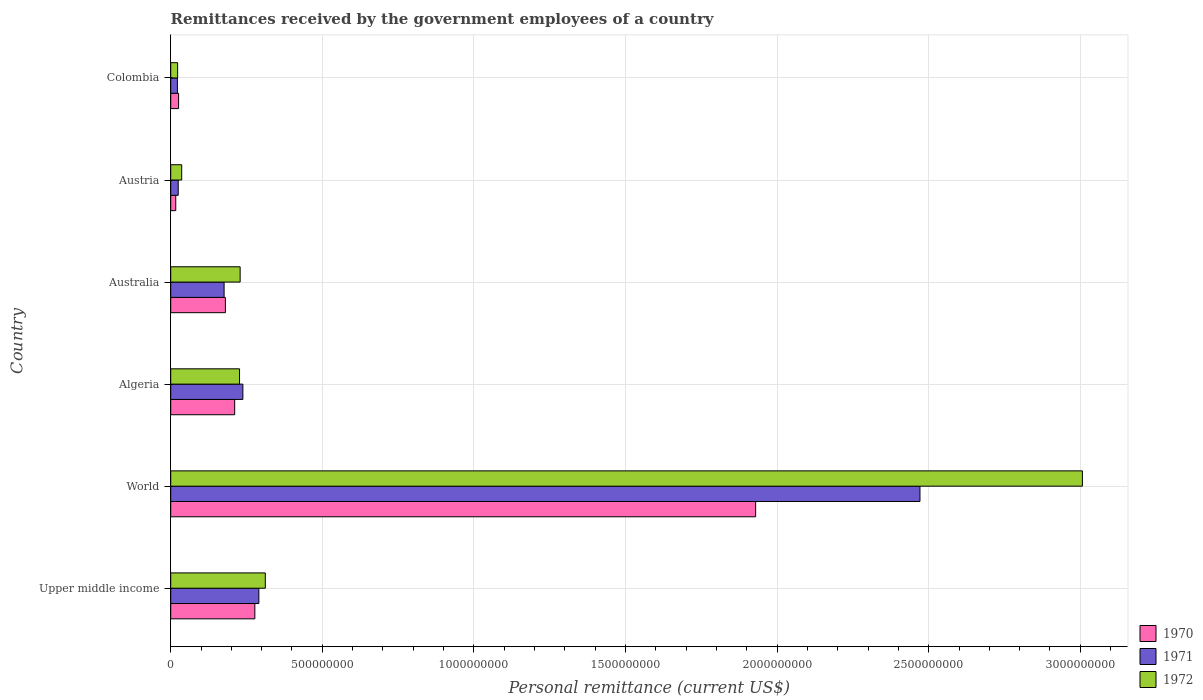Are the number of bars on each tick of the Y-axis equal?
Offer a terse response. Yes. How many bars are there on the 6th tick from the bottom?
Offer a terse response. 3. What is the label of the 6th group of bars from the top?
Offer a very short reply. Upper middle income. What is the remittances received by the government employees in 1970 in Austria?
Give a very brief answer. 1.66e+07. Across all countries, what is the maximum remittances received by the government employees in 1970?
Provide a succinct answer. 1.93e+09. Across all countries, what is the minimum remittances received by the government employees in 1970?
Keep it short and to the point. 1.66e+07. In which country was the remittances received by the government employees in 1972 maximum?
Give a very brief answer. World. In which country was the remittances received by the government employees in 1970 minimum?
Offer a very short reply. Austria. What is the total remittances received by the government employees in 1972 in the graph?
Offer a very short reply. 3.83e+09. What is the difference between the remittances received by the government employees in 1972 in Austria and that in Colombia?
Keep it short and to the point. 1.34e+07. What is the difference between the remittances received by the government employees in 1972 in Algeria and the remittances received by the government employees in 1970 in Austria?
Your answer should be compact. 2.10e+08. What is the average remittances received by the government employees in 1971 per country?
Provide a succinct answer. 5.37e+08. What is the difference between the remittances received by the government employees in 1971 and remittances received by the government employees in 1972 in Austria?
Your response must be concise. -1.15e+07. What is the ratio of the remittances received by the government employees in 1972 in Colombia to that in World?
Provide a succinct answer. 0.01. Is the remittances received by the government employees in 1971 in Austria less than that in World?
Give a very brief answer. Yes. What is the difference between the highest and the second highest remittances received by the government employees in 1970?
Your answer should be compact. 1.65e+09. What is the difference between the highest and the lowest remittances received by the government employees in 1971?
Your response must be concise. 2.45e+09. In how many countries, is the remittances received by the government employees in 1971 greater than the average remittances received by the government employees in 1971 taken over all countries?
Provide a succinct answer. 1. Is the sum of the remittances received by the government employees in 1970 in Australia and Colombia greater than the maximum remittances received by the government employees in 1972 across all countries?
Provide a succinct answer. No. What does the 1st bar from the top in Algeria represents?
Give a very brief answer. 1972. Are all the bars in the graph horizontal?
Your response must be concise. Yes. What is the difference between two consecutive major ticks on the X-axis?
Keep it short and to the point. 5.00e+08. Are the values on the major ticks of X-axis written in scientific E-notation?
Give a very brief answer. No. Where does the legend appear in the graph?
Your response must be concise. Bottom right. How many legend labels are there?
Provide a succinct answer. 3. How are the legend labels stacked?
Keep it short and to the point. Vertical. What is the title of the graph?
Your answer should be very brief. Remittances received by the government employees of a country. Does "2006" appear as one of the legend labels in the graph?
Provide a succinct answer. No. What is the label or title of the X-axis?
Provide a short and direct response. Personal remittance (current US$). What is the label or title of the Y-axis?
Provide a short and direct response. Country. What is the Personal remittance (current US$) in 1970 in Upper middle income?
Ensure brevity in your answer.  2.77e+08. What is the Personal remittance (current US$) in 1971 in Upper middle income?
Your response must be concise. 2.91e+08. What is the Personal remittance (current US$) of 1972 in Upper middle income?
Your answer should be compact. 3.12e+08. What is the Personal remittance (current US$) of 1970 in World?
Offer a very short reply. 1.93e+09. What is the Personal remittance (current US$) of 1971 in World?
Give a very brief answer. 2.47e+09. What is the Personal remittance (current US$) of 1972 in World?
Ensure brevity in your answer.  3.01e+09. What is the Personal remittance (current US$) in 1970 in Algeria?
Give a very brief answer. 2.11e+08. What is the Personal remittance (current US$) of 1971 in Algeria?
Give a very brief answer. 2.38e+08. What is the Personal remittance (current US$) in 1972 in Algeria?
Your answer should be very brief. 2.27e+08. What is the Personal remittance (current US$) in 1970 in Australia?
Make the answer very short. 1.80e+08. What is the Personal remittance (current US$) of 1971 in Australia?
Your response must be concise. 1.76e+08. What is the Personal remittance (current US$) in 1972 in Australia?
Provide a short and direct response. 2.29e+08. What is the Personal remittance (current US$) in 1970 in Austria?
Offer a terse response. 1.66e+07. What is the Personal remittance (current US$) of 1971 in Austria?
Your answer should be compact. 2.48e+07. What is the Personal remittance (current US$) of 1972 in Austria?
Keep it short and to the point. 3.62e+07. What is the Personal remittance (current US$) of 1970 in Colombia?
Ensure brevity in your answer.  2.60e+07. What is the Personal remittance (current US$) in 1971 in Colombia?
Your answer should be compact. 2.21e+07. What is the Personal remittance (current US$) of 1972 in Colombia?
Your response must be concise. 2.28e+07. Across all countries, what is the maximum Personal remittance (current US$) in 1970?
Offer a terse response. 1.93e+09. Across all countries, what is the maximum Personal remittance (current US$) of 1971?
Offer a terse response. 2.47e+09. Across all countries, what is the maximum Personal remittance (current US$) of 1972?
Offer a terse response. 3.01e+09. Across all countries, what is the minimum Personal remittance (current US$) of 1970?
Your answer should be compact. 1.66e+07. Across all countries, what is the minimum Personal remittance (current US$) in 1971?
Offer a terse response. 2.21e+07. Across all countries, what is the minimum Personal remittance (current US$) of 1972?
Your answer should be very brief. 2.28e+07. What is the total Personal remittance (current US$) of 1970 in the graph?
Your answer should be very brief. 2.64e+09. What is the total Personal remittance (current US$) in 1971 in the graph?
Give a very brief answer. 3.22e+09. What is the total Personal remittance (current US$) in 1972 in the graph?
Your answer should be compact. 3.83e+09. What is the difference between the Personal remittance (current US$) of 1970 in Upper middle income and that in World?
Ensure brevity in your answer.  -1.65e+09. What is the difference between the Personal remittance (current US$) of 1971 in Upper middle income and that in World?
Your answer should be very brief. -2.18e+09. What is the difference between the Personal remittance (current US$) of 1972 in Upper middle income and that in World?
Offer a very short reply. -2.70e+09. What is the difference between the Personal remittance (current US$) in 1970 in Upper middle income and that in Algeria?
Ensure brevity in your answer.  6.65e+07. What is the difference between the Personal remittance (current US$) of 1971 in Upper middle income and that in Algeria?
Provide a short and direct response. 5.27e+07. What is the difference between the Personal remittance (current US$) in 1972 in Upper middle income and that in Algeria?
Ensure brevity in your answer.  8.50e+07. What is the difference between the Personal remittance (current US$) of 1970 in Upper middle income and that in Australia?
Provide a succinct answer. 9.72e+07. What is the difference between the Personal remittance (current US$) of 1971 in Upper middle income and that in Australia?
Your answer should be compact. 1.15e+08. What is the difference between the Personal remittance (current US$) of 1972 in Upper middle income and that in Australia?
Offer a terse response. 8.30e+07. What is the difference between the Personal remittance (current US$) of 1970 in Upper middle income and that in Austria?
Make the answer very short. 2.61e+08. What is the difference between the Personal remittance (current US$) of 1971 in Upper middle income and that in Austria?
Your response must be concise. 2.66e+08. What is the difference between the Personal remittance (current US$) of 1972 in Upper middle income and that in Austria?
Keep it short and to the point. 2.76e+08. What is the difference between the Personal remittance (current US$) in 1970 in Upper middle income and that in Colombia?
Provide a short and direct response. 2.51e+08. What is the difference between the Personal remittance (current US$) in 1971 in Upper middle income and that in Colombia?
Keep it short and to the point. 2.69e+08. What is the difference between the Personal remittance (current US$) in 1972 in Upper middle income and that in Colombia?
Your answer should be very brief. 2.89e+08. What is the difference between the Personal remittance (current US$) in 1970 in World and that in Algeria?
Provide a succinct answer. 1.72e+09. What is the difference between the Personal remittance (current US$) in 1971 in World and that in Algeria?
Your answer should be compact. 2.23e+09. What is the difference between the Personal remittance (current US$) of 1972 in World and that in Algeria?
Offer a very short reply. 2.78e+09. What is the difference between the Personal remittance (current US$) of 1970 in World and that in Australia?
Offer a very short reply. 1.75e+09. What is the difference between the Personal remittance (current US$) in 1971 in World and that in Australia?
Ensure brevity in your answer.  2.30e+09. What is the difference between the Personal remittance (current US$) of 1972 in World and that in Australia?
Provide a succinct answer. 2.78e+09. What is the difference between the Personal remittance (current US$) in 1970 in World and that in Austria?
Make the answer very short. 1.91e+09. What is the difference between the Personal remittance (current US$) of 1971 in World and that in Austria?
Provide a short and direct response. 2.45e+09. What is the difference between the Personal remittance (current US$) in 1972 in World and that in Austria?
Ensure brevity in your answer.  2.97e+09. What is the difference between the Personal remittance (current US$) of 1970 in World and that in Colombia?
Provide a succinct answer. 1.90e+09. What is the difference between the Personal remittance (current US$) of 1971 in World and that in Colombia?
Provide a succinct answer. 2.45e+09. What is the difference between the Personal remittance (current US$) of 1972 in World and that in Colombia?
Keep it short and to the point. 2.98e+09. What is the difference between the Personal remittance (current US$) in 1970 in Algeria and that in Australia?
Offer a very short reply. 3.07e+07. What is the difference between the Personal remittance (current US$) of 1971 in Algeria and that in Australia?
Keep it short and to the point. 6.20e+07. What is the difference between the Personal remittance (current US$) of 1972 in Algeria and that in Australia?
Your answer should be very brief. -1.96e+06. What is the difference between the Personal remittance (current US$) in 1970 in Algeria and that in Austria?
Give a very brief answer. 1.94e+08. What is the difference between the Personal remittance (current US$) of 1971 in Algeria and that in Austria?
Make the answer very short. 2.13e+08. What is the difference between the Personal remittance (current US$) in 1972 in Algeria and that in Austria?
Provide a succinct answer. 1.91e+08. What is the difference between the Personal remittance (current US$) of 1970 in Algeria and that in Colombia?
Ensure brevity in your answer.  1.85e+08. What is the difference between the Personal remittance (current US$) of 1971 in Algeria and that in Colombia?
Your answer should be compact. 2.16e+08. What is the difference between the Personal remittance (current US$) of 1972 in Algeria and that in Colombia?
Give a very brief answer. 2.04e+08. What is the difference between the Personal remittance (current US$) of 1970 in Australia and that in Austria?
Your response must be concise. 1.64e+08. What is the difference between the Personal remittance (current US$) in 1971 in Australia and that in Austria?
Provide a succinct answer. 1.51e+08. What is the difference between the Personal remittance (current US$) in 1972 in Australia and that in Austria?
Offer a terse response. 1.93e+08. What is the difference between the Personal remittance (current US$) in 1970 in Australia and that in Colombia?
Keep it short and to the point. 1.54e+08. What is the difference between the Personal remittance (current US$) in 1971 in Australia and that in Colombia?
Make the answer very short. 1.54e+08. What is the difference between the Personal remittance (current US$) in 1972 in Australia and that in Colombia?
Ensure brevity in your answer.  2.06e+08. What is the difference between the Personal remittance (current US$) of 1970 in Austria and that in Colombia?
Provide a short and direct response. -9.42e+06. What is the difference between the Personal remittance (current US$) in 1971 in Austria and that in Colombia?
Make the answer very short. 2.69e+06. What is the difference between the Personal remittance (current US$) in 1972 in Austria and that in Colombia?
Offer a very short reply. 1.34e+07. What is the difference between the Personal remittance (current US$) of 1970 in Upper middle income and the Personal remittance (current US$) of 1971 in World?
Offer a terse response. -2.19e+09. What is the difference between the Personal remittance (current US$) in 1970 in Upper middle income and the Personal remittance (current US$) in 1972 in World?
Your response must be concise. -2.73e+09. What is the difference between the Personal remittance (current US$) in 1971 in Upper middle income and the Personal remittance (current US$) in 1972 in World?
Give a very brief answer. -2.72e+09. What is the difference between the Personal remittance (current US$) of 1970 in Upper middle income and the Personal remittance (current US$) of 1971 in Algeria?
Make the answer very short. 3.95e+07. What is the difference between the Personal remittance (current US$) in 1970 in Upper middle income and the Personal remittance (current US$) in 1972 in Algeria?
Your answer should be very brief. 5.05e+07. What is the difference between the Personal remittance (current US$) in 1971 in Upper middle income and the Personal remittance (current US$) in 1972 in Algeria?
Provide a succinct answer. 6.37e+07. What is the difference between the Personal remittance (current US$) in 1970 in Upper middle income and the Personal remittance (current US$) in 1971 in Australia?
Offer a terse response. 1.01e+08. What is the difference between the Personal remittance (current US$) in 1970 in Upper middle income and the Personal remittance (current US$) in 1972 in Australia?
Your answer should be very brief. 4.85e+07. What is the difference between the Personal remittance (current US$) in 1971 in Upper middle income and the Personal remittance (current US$) in 1972 in Australia?
Provide a succinct answer. 6.18e+07. What is the difference between the Personal remittance (current US$) of 1970 in Upper middle income and the Personal remittance (current US$) of 1971 in Austria?
Make the answer very short. 2.53e+08. What is the difference between the Personal remittance (current US$) of 1970 in Upper middle income and the Personal remittance (current US$) of 1972 in Austria?
Your response must be concise. 2.41e+08. What is the difference between the Personal remittance (current US$) of 1971 in Upper middle income and the Personal remittance (current US$) of 1972 in Austria?
Make the answer very short. 2.54e+08. What is the difference between the Personal remittance (current US$) in 1970 in Upper middle income and the Personal remittance (current US$) in 1971 in Colombia?
Keep it short and to the point. 2.55e+08. What is the difference between the Personal remittance (current US$) in 1970 in Upper middle income and the Personal remittance (current US$) in 1972 in Colombia?
Your response must be concise. 2.55e+08. What is the difference between the Personal remittance (current US$) in 1971 in Upper middle income and the Personal remittance (current US$) in 1972 in Colombia?
Provide a succinct answer. 2.68e+08. What is the difference between the Personal remittance (current US$) in 1970 in World and the Personal remittance (current US$) in 1971 in Algeria?
Your response must be concise. 1.69e+09. What is the difference between the Personal remittance (current US$) of 1970 in World and the Personal remittance (current US$) of 1972 in Algeria?
Provide a short and direct response. 1.70e+09. What is the difference between the Personal remittance (current US$) of 1971 in World and the Personal remittance (current US$) of 1972 in Algeria?
Your answer should be very brief. 2.24e+09. What is the difference between the Personal remittance (current US$) in 1970 in World and the Personal remittance (current US$) in 1971 in Australia?
Offer a terse response. 1.75e+09. What is the difference between the Personal remittance (current US$) of 1970 in World and the Personal remittance (current US$) of 1972 in Australia?
Offer a terse response. 1.70e+09. What is the difference between the Personal remittance (current US$) in 1971 in World and the Personal remittance (current US$) in 1972 in Australia?
Your answer should be very brief. 2.24e+09. What is the difference between the Personal remittance (current US$) in 1970 in World and the Personal remittance (current US$) in 1971 in Austria?
Make the answer very short. 1.90e+09. What is the difference between the Personal remittance (current US$) in 1970 in World and the Personal remittance (current US$) in 1972 in Austria?
Your response must be concise. 1.89e+09. What is the difference between the Personal remittance (current US$) of 1971 in World and the Personal remittance (current US$) of 1972 in Austria?
Keep it short and to the point. 2.44e+09. What is the difference between the Personal remittance (current US$) in 1970 in World and the Personal remittance (current US$) in 1971 in Colombia?
Make the answer very short. 1.91e+09. What is the difference between the Personal remittance (current US$) in 1970 in World and the Personal remittance (current US$) in 1972 in Colombia?
Provide a succinct answer. 1.91e+09. What is the difference between the Personal remittance (current US$) of 1971 in World and the Personal remittance (current US$) of 1972 in Colombia?
Provide a succinct answer. 2.45e+09. What is the difference between the Personal remittance (current US$) in 1970 in Algeria and the Personal remittance (current US$) in 1971 in Australia?
Your answer should be compact. 3.50e+07. What is the difference between the Personal remittance (current US$) of 1970 in Algeria and the Personal remittance (current US$) of 1972 in Australia?
Make the answer very short. -1.80e+07. What is the difference between the Personal remittance (current US$) of 1971 in Algeria and the Personal remittance (current US$) of 1972 in Australia?
Provide a short and direct response. 9.04e+06. What is the difference between the Personal remittance (current US$) of 1970 in Algeria and the Personal remittance (current US$) of 1971 in Austria?
Offer a terse response. 1.86e+08. What is the difference between the Personal remittance (current US$) in 1970 in Algeria and the Personal remittance (current US$) in 1972 in Austria?
Provide a short and direct response. 1.75e+08. What is the difference between the Personal remittance (current US$) in 1971 in Algeria and the Personal remittance (current US$) in 1972 in Austria?
Provide a short and direct response. 2.02e+08. What is the difference between the Personal remittance (current US$) of 1970 in Algeria and the Personal remittance (current US$) of 1971 in Colombia?
Your response must be concise. 1.89e+08. What is the difference between the Personal remittance (current US$) in 1970 in Algeria and the Personal remittance (current US$) in 1972 in Colombia?
Ensure brevity in your answer.  1.88e+08. What is the difference between the Personal remittance (current US$) of 1971 in Algeria and the Personal remittance (current US$) of 1972 in Colombia?
Your response must be concise. 2.15e+08. What is the difference between the Personal remittance (current US$) in 1970 in Australia and the Personal remittance (current US$) in 1971 in Austria?
Your answer should be very brief. 1.56e+08. What is the difference between the Personal remittance (current US$) of 1970 in Australia and the Personal remittance (current US$) of 1972 in Austria?
Offer a very short reply. 1.44e+08. What is the difference between the Personal remittance (current US$) of 1971 in Australia and the Personal remittance (current US$) of 1972 in Austria?
Ensure brevity in your answer.  1.40e+08. What is the difference between the Personal remittance (current US$) of 1970 in Australia and the Personal remittance (current US$) of 1971 in Colombia?
Provide a short and direct response. 1.58e+08. What is the difference between the Personal remittance (current US$) of 1970 in Australia and the Personal remittance (current US$) of 1972 in Colombia?
Your answer should be very brief. 1.58e+08. What is the difference between the Personal remittance (current US$) of 1971 in Australia and the Personal remittance (current US$) of 1972 in Colombia?
Ensure brevity in your answer.  1.53e+08. What is the difference between the Personal remittance (current US$) of 1970 in Austria and the Personal remittance (current US$) of 1971 in Colombia?
Provide a short and direct response. -5.49e+06. What is the difference between the Personal remittance (current US$) in 1970 in Austria and the Personal remittance (current US$) in 1972 in Colombia?
Offer a very short reply. -6.22e+06. What is the difference between the Personal remittance (current US$) of 1971 in Austria and the Personal remittance (current US$) of 1972 in Colombia?
Your answer should be compact. 1.96e+06. What is the average Personal remittance (current US$) of 1970 per country?
Give a very brief answer. 4.40e+08. What is the average Personal remittance (current US$) in 1971 per country?
Your answer should be very brief. 5.37e+08. What is the average Personal remittance (current US$) of 1972 per country?
Offer a terse response. 6.39e+08. What is the difference between the Personal remittance (current US$) of 1970 and Personal remittance (current US$) of 1971 in Upper middle income?
Your response must be concise. -1.32e+07. What is the difference between the Personal remittance (current US$) in 1970 and Personal remittance (current US$) in 1972 in Upper middle income?
Make the answer very short. -3.45e+07. What is the difference between the Personal remittance (current US$) of 1971 and Personal remittance (current US$) of 1972 in Upper middle income?
Provide a succinct answer. -2.13e+07. What is the difference between the Personal remittance (current US$) in 1970 and Personal remittance (current US$) in 1971 in World?
Offer a terse response. -5.42e+08. What is the difference between the Personal remittance (current US$) of 1970 and Personal remittance (current US$) of 1972 in World?
Make the answer very short. -1.08e+09. What is the difference between the Personal remittance (current US$) in 1971 and Personal remittance (current US$) in 1972 in World?
Give a very brief answer. -5.36e+08. What is the difference between the Personal remittance (current US$) of 1970 and Personal remittance (current US$) of 1971 in Algeria?
Ensure brevity in your answer.  -2.70e+07. What is the difference between the Personal remittance (current US$) in 1970 and Personal remittance (current US$) in 1972 in Algeria?
Provide a short and direct response. -1.60e+07. What is the difference between the Personal remittance (current US$) of 1971 and Personal remittance (current US$) of 1972 in Algeria?
Make the answer very short. 1.10e+07. What is the difference between the Personal remittance (current US$) of 1970 and Personal remittance (current US$) of 1971 in Australia?
Provide a short and direct response. 4.27e+06. What is the difference between the Personal remittance (current US$) in 1970 and Personal remittance (current US$) in 1972 in Australia?
Offer a very short reply. -4.86e+07. What is the difference between the Personal remittance (current US$) in 1971 and Personal remittance (current US$) in 1972 in Australia?
Offer a very short reply. -5.29e+07. What is the difference between the Personal remittance (current US$) in 1970 and Personal remittance (current US$) in 1971 in Austria?
Ensure brevity in your answer.  -8.18e+06. What is the difference between the Personal remittance (current US$) in 1970 and Personal remittance (current US$) in 1972 in Austria?
Keep it short and to the point. -1.97e+07. What is the difference between the Personal remittance (current US$) in 1971 and Personal remittance (current US$) in 1972 in Austria?
Ensure brevity in your answer.  -1.15e+07. What is the difference between the Personal remittance (current US$) of 1970 and Personal remittance (current US$) of 1971 in Colombia?
Your response must be concise. 3.93e+06. What is the difference between the Personal remittance (current US$) of 1970 and Personal remittance (current US$) of 1972 in Colombia?
Keep it short and to the point. 3.20e+06. What is the difference between the Personal remittance (current US$) of 1971 and Personal remittance (current US$) of 1972 in Colombia?
Make the answer very short. -7.34e+05. What is the ratio of the Personal remittance (current US$) of 1970 in Upper middle income to that in World?
Give a very brief answer. 0.14. What is the ratio of the Personal remittance (current US$) of 1971 in Upper middle income to that in World?
Provide a succinct answer. 0.12. What is the ratio of the Personal remittance (current US$) of 1972 in Upper middle income to that in World?
Offer a very short reply. 0.1. What is the ratio of the Personal remittance (current US$) in 1970 in Upper middle income to that in Algeria?
Provide a short and direct response. 1.32. What is the ratio of the Personal remittance (current US$) of 1971 in Upper middle income to that in Algeria?
Make the answer very short. 1.22. What is the ratio of the Personal remittance (current US$) of 1972 in Upper middle income to that in Algeria?
Keep it short and to the point. 1.37. What is the ratio of the Personal remittance (current US$) of 1970 in Upper middle income to that in Australia?
Give a very brief answer. 1.54. What is the ratio of the Personal remittance (current US$) in 1971 in Upper middle income to that in Australia?
Offer a terse response. 1.65. What is the ratio of the Personal remittance (current US$) of 1972 in Upper middle income to that in Australia?
Your answer should be compact. 1.36. What is the ratio of the Personal remittance (current US$) in 1970 in Upper middle income to that in Austria?
Make the answer very short. 16.74. What is the ratio of the Personal remittance (current US$) in 1971 in Upper middle income to that in Austria?
Make the answer very short. 11.74. What is the ratio of the Personal remittance (current US$) of 1972 in Upper middle income to that in Austria?
Your answer should be very brief. 8.61. What is the ratio of the Personal remittance (current US$) of 1970 in Upper middle income to that in Colombia?
Give a very brief answer. 10.67. What is the ratio of the Personal remittance (current US$) in 1971 in Upper middle income to that in Colombia?
Your response must be concise. 13.18. What is the ratio of the Personal remittance (current US$) of 1972 in Upper middle income to that in Colombia?
Give a very brief answer. 13.68. What is the ratio of the Personal remittance (current US$) in 1970 in World to that in Algeria?
Provide a short and direct response. 9.14. What is the ratio of the Personal remittance (current US$) of 1971 in World to that in Algeria?
Provide a short and direct response. 10.38. What is the ratio of the Personal remittance (current US$) in 1972 in World to that in Algeria?
Offer a very short reply. 13.25. What is the ratio of the Personal remittance (current US$) of 1970 in World to that in Australia?
Provide a short and direct response. 10.7. What is the ratio of the Personal remittance (current US$) in 1971 in World to that in Australia?
Keep it short and to the point. 14.04. What is the ratio of the Personal remittance (current US$) in 1972 in World to that in Australia?
Give a very brief answer. 13.13. What is the ratio of the Personal remittance (current US$) in 1970 in World to that in Austria?
Offer a very short reply. 116.38. What is the ratio of the Personal remittance (current US$) of 1971 in World to that in Austria?
Keep it short and to the point. 99.81. What is the ratio of the Personal remittance (current US$) in 1972 in World to that in Austria?
Your answer should be very brief. 82.96. What is the ratio of the Personal remittance (current US$) of 1970 in World to that in Colombia?
Your response must be concise. 74.2. What is the ratio of the Personal remittance (current US$) of 1971 in World to that in Colombia?
Give a very brief answer. 112. What is the ratio of the Personal remittance (current US$) of 1972 in World to that in Colombia?
Ensure brevity in your answer.  131.89. What is the ratio of the Personal remittance (current US$) of 1970 in Algeria to that in Australia?
Ensure brevity in your answer.  1.17. What is the ratio of the Personal remittance (current US$) in 1971 in Algeria to that in Australia?
Make the answer very short. 1.35. What is the ratio of the Personal remittance (current US$) of 1972 in Algeria to that in Australia?
Provide a succinct answer. 0.99. What is the ratio of the Personal remittance (current US$) of 1970 in Algeria to that in Austria?
Your response must be concise. 12.73. What is the ratio of the Personal remittance (current US$) of 1971 in Algeria to that in Austria?
Ensure brevity in your answer.  9.61. What is the ratio of the Personal remittance (current US$) of 1972 in Algeria to that in Austria?
Provide a short and direct response. 6.26. What is the ratio of the Personal remittance (current US$) in 1970 in Algeria to that in Colombia?
Your response must be concise. 8.12. What is the ratio of the Personal remittance (current US$) in 1971 in Algeria to that in Colombia?
Your response must be concise. 10.79. What is the ratio of the Personal remittance (current US$) in 1972 in Algeria to that in Colombia?
Offer a terse response. 9.96. What is the ratio of the Personal remittance (current US$) of 1970 in Australia to that in Austria?
Provide a succinct answer. 10.88. What is the ratio of the Personal remittance (current US$) of 1971 in Australia to that in Austria?
Your answer should be very brief. 7.11. What is the ratio of the Personal remittance (current US$) in 1972 in Australia to that in Austria?
Offer a very short reply. 6.32. What is the ratio of the Personal remittance (current US$) in 1970 in Australia to that in Colombia?
Your answer should be very brief. 6.94. What is the ratio of the Personal remittance (current US$) in 1971 in Australia to that in Colombia?
Ensure brevity in your answer.  7.98. What is the ratio of the Personal remittance (current US$) in 1972 in Australia to that in Colombia?
Your answer should be compact. 10.04. What is the ratio of the Personal remittance (current US$) in 1970 in Austria to that in Colombia?
Provide a succinct answer. 0.64. What is the ratio of the Personal remittance (current US$) in 1971 in Austria to that in Colombia?
Ensure brevity in your answer.  1.12. What is the ratio of the Personal remittance (current US$) of 1972 in Austria to that in Colombia?
Provide a short and direct response. 1.59. What is the difference between the highest and the second highest Personal remittance (current US$) in 1970?
Offer a very short reply. 1.65e+09. What is the difference between the highest and the second highest Personal remittance (current US$) in 1971?
Your answer should be compact. 2.18e+09. What is the difference between the highest and the second highest Personal remittance (current US$) of 1972?
Provide a succinct answer. 2.70e+09. What is the difference between the highest and the lowest Personal remittance (current US$) of 1970?
Your answer should be compact. 1.91e+09. What is the difference between the highest and the lowest Personal remittance (current US$) of 1971?
Offer a very short reply. 2.45e+09. What is the difference between the highest and the lowest Personal remittance (current US$) in 1972?
Your answer should be compact. 2.98e+09. 